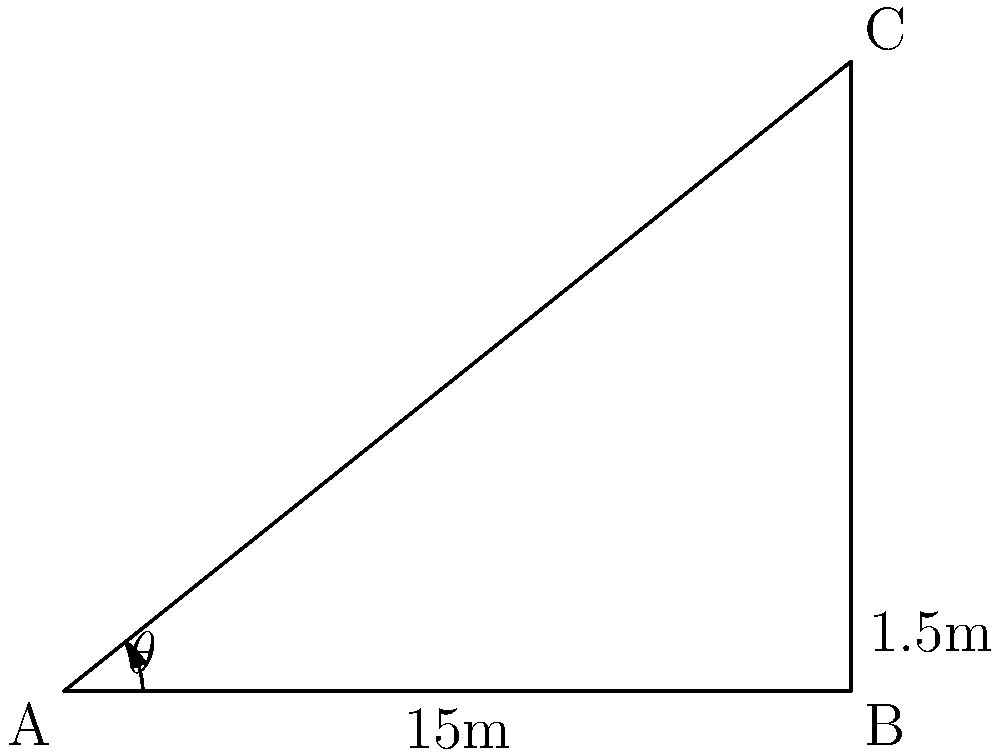At the US Open, you notice a tennis net pole and want to estimate its height. Standing 15 meters away from the base of the pole, you use a clinometer and measure the angle of elevation to the top of the pole to be $\theta$. You know that the bottom 1.5 meters of the pole is below ground level. If $\tan(\theta) = 0.6$, what is the total height of the tennis net pole, including the part below ground? Let's approach this step-by-step:

1) First, let's identify what we know:
   - The distance from you to the base of the pole is 15 meters
   - $\tan(\theta) = 0.6$
   - 1.5 meters of the pole is below ground

2) We can use the tangent ratio to find the height of the visible part of the pole:
   $\tan(\theta) = \frac{\text{opposite}}{\text{adjacent}} = \frac{\text{visible height}}{15}$

3) Substituting the known value:
   $0.6 = \frac{\text{visible height}}{15}$

4) Solving for the visible height:
   $\text{visible height} = 0.6 \times 15 = 9$ meters

5) Now, we need to add the part of the pole that's below ground:
   $\text{total height} = \text{visible height} + \text{underground part}$
   $\text{total height} = 9 + 1.5 = 10.5$ meters

Therefore, the total height of the tennis net pole is 10.5 meters.
Answer: 10.5 meters 